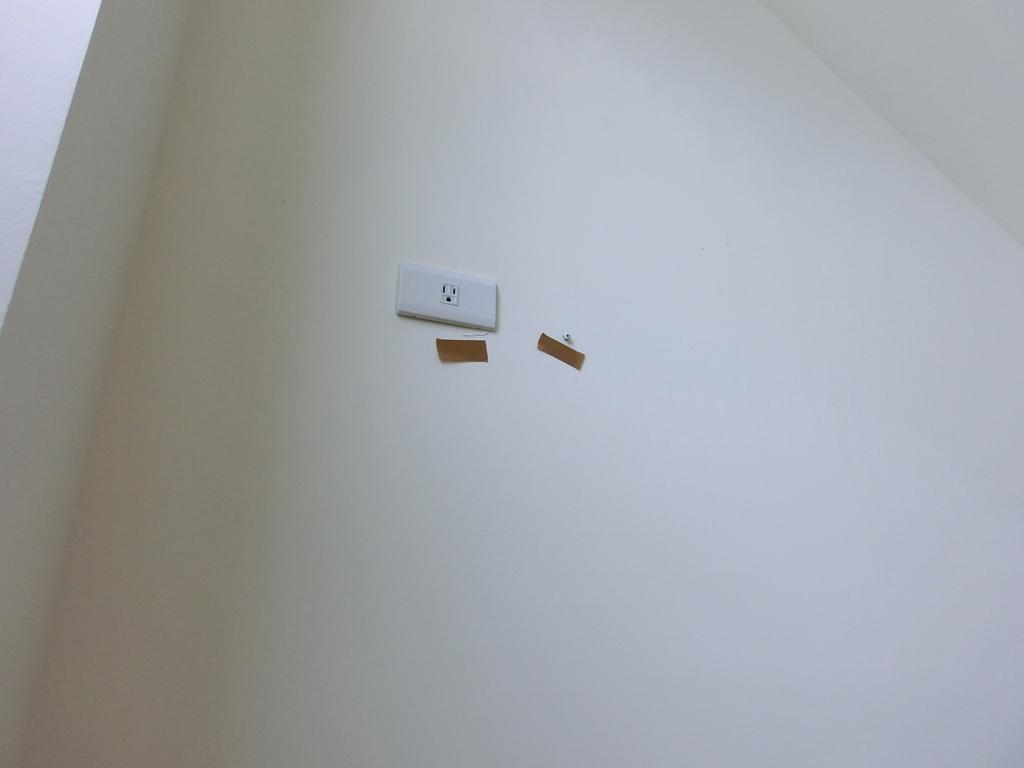What can be seen on the wall in the image? There is a socket on the wall in the image. Can you tell me how many divisions are present in the image? The image does not show any divisions or mathematical concepts; it only shows a socket on the wall. What type of haircut is the ant getting in the image? There is no ant present in the image, and therefore no haircut can be observed. 